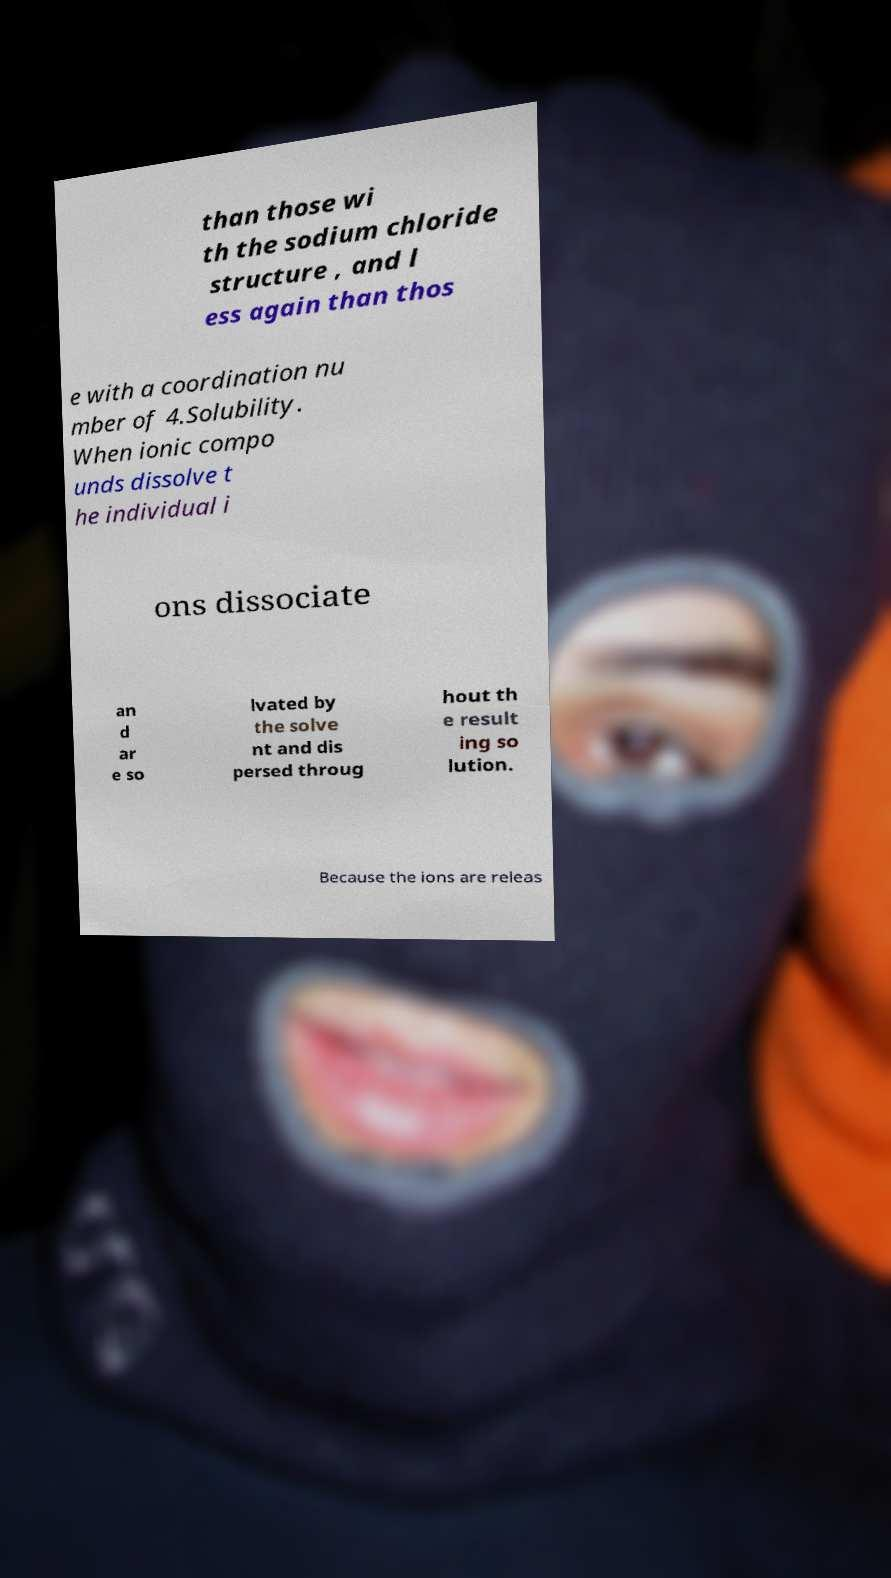There's text embedded in this image that I need extracted. Can you transcribe it verbatim? than those wi th the sodium chloride structure , and l ess again than thos e with a coordination nu mber of 4.Solubility. When ionic compo unds dissolve t he individual i ons dissociate an d ar e so lvated by the solve nt and dis persed throug hout th e result ing so lution. Because the ions are releas 